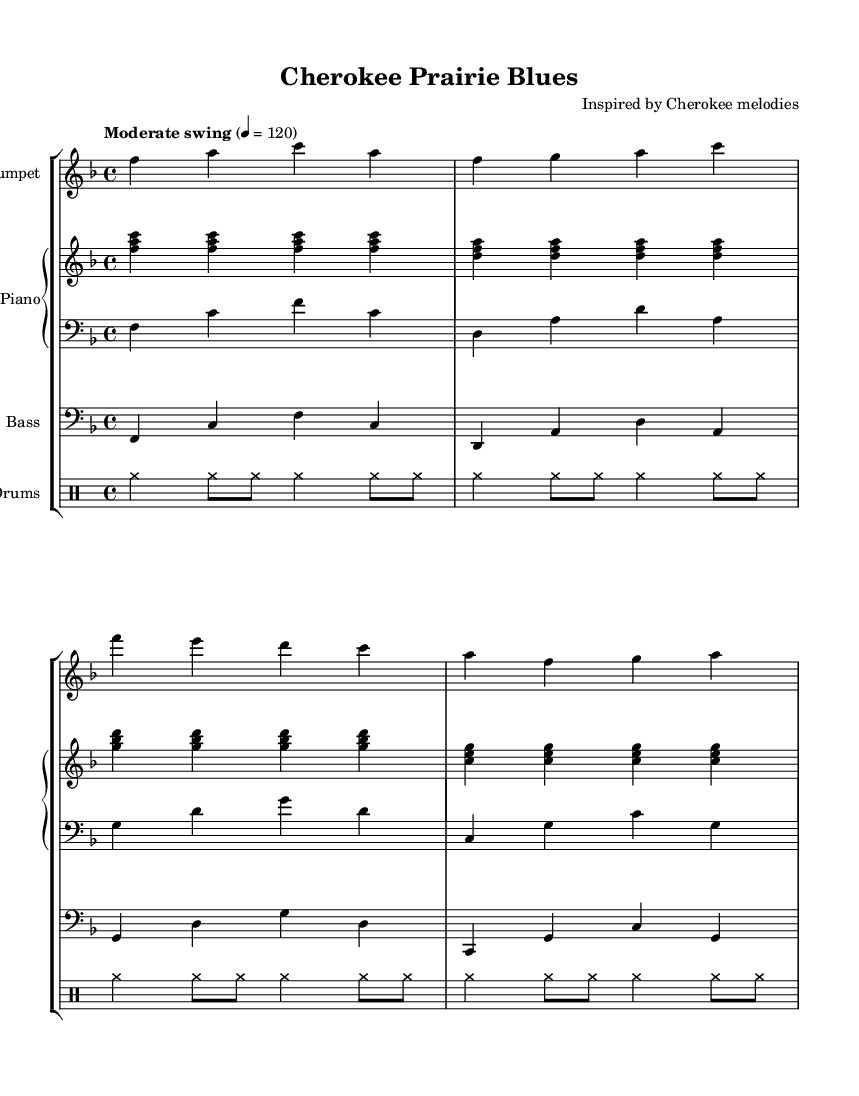What is the time signature of this music? The time signature is the number of beats in each measure, indicated at the beginning of the sheet by the "4/4" symbol. This means there are 4 beats per measure.
Answer: 4/4 What is the key signature of this music? The key signature is indicated by the presence of flats or sharps at the beginning of the staff. In this case, there are no sharps or flats, which indicates the key of F major.
Answer: F major What tempo marking is given for this piece? The tempo marking is indicated above the staff as "Moderate swing" and a number referring to beats per minute. It specifies the swing style and a tempo of 120 beats per minute.
Answer: Moderate swing How many measures are in the trumpet part? By counting the number of vertical bar lines, which represent the end of each measure, we find there are 4 measures in the trumpet part.
Answer: 4 What kind of rhythm is indicated for the drums part? The rhythm for the drums is described in the drummode section using terms like "cymr" (for cymbal hits), which defines the overall rhythmic pattern. This pattern uses repeated figures in a swing style, typical for jazz music.
Answer: Swing pattern What is the name of the piece? The title of the piece is presented in the header section at the top of the sheet music. It indicates that the composition is called "Cherokee Prairie Blues."
Answer: Cherokee Prairie Blues Which instrument has the highest pitch in this arrangement? The trumpet part is written in a higher octave compared to the piano and bass parts, making it the highest-pitched instrument in this score.
Answer: Trumpet 